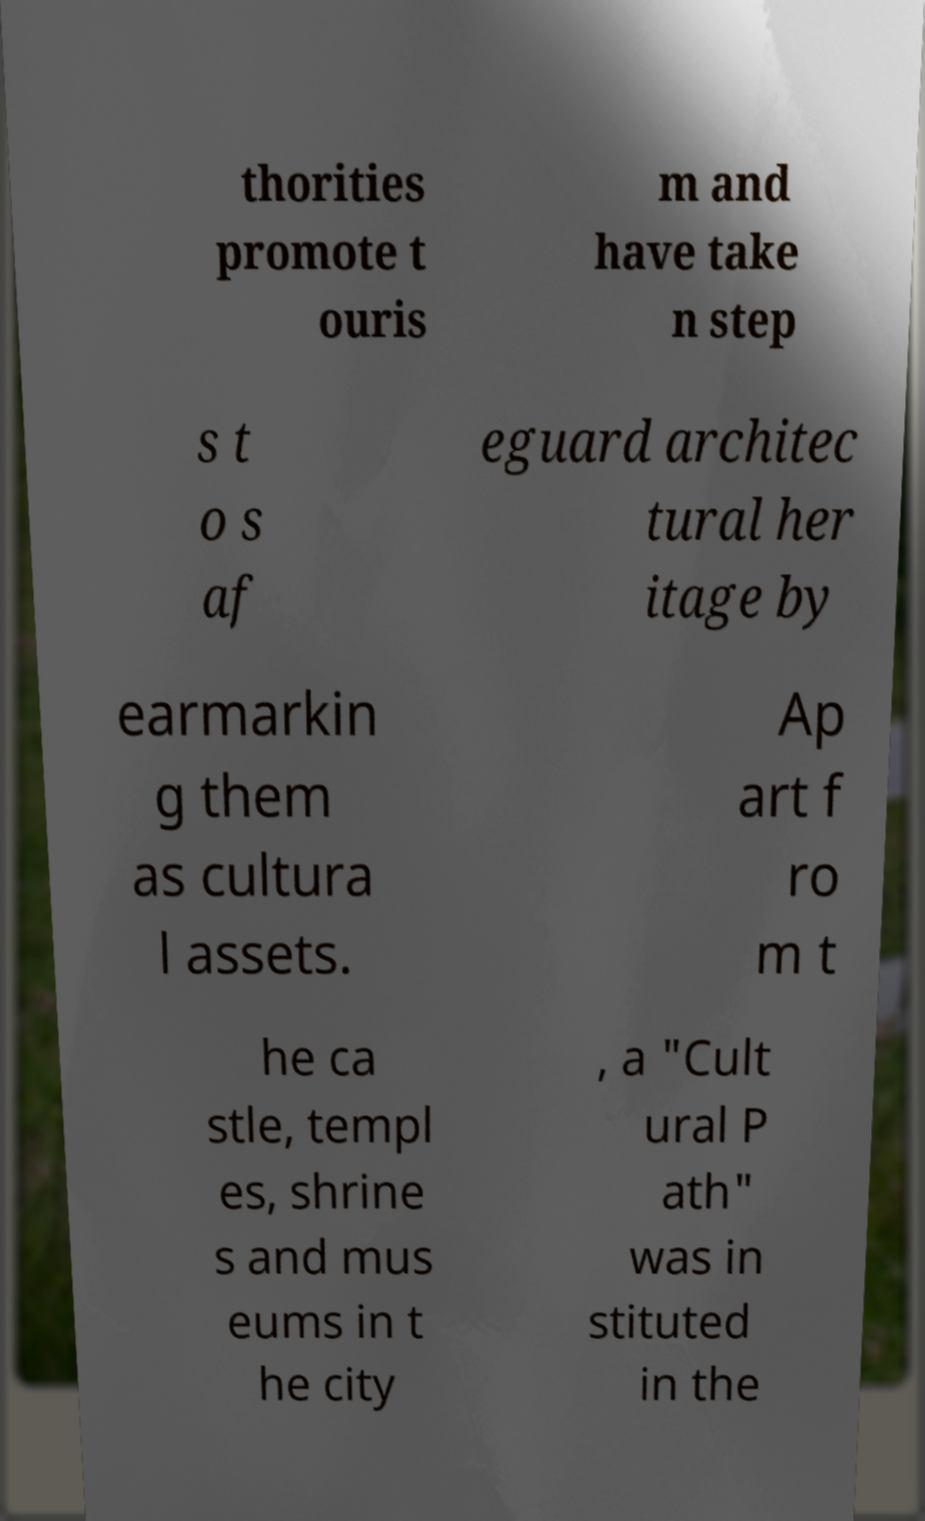I need the written content from this picture converted into text. Can you do that? thorities promote t ouris m and have take n step s t o s af eguard architec tural her itage by earmarkin g them as cultura l assets. Ap art f ro m t he ca stle, templ es, shrine s and mus eums in t he city , a "Cult ural P ath" was in stituted in the 